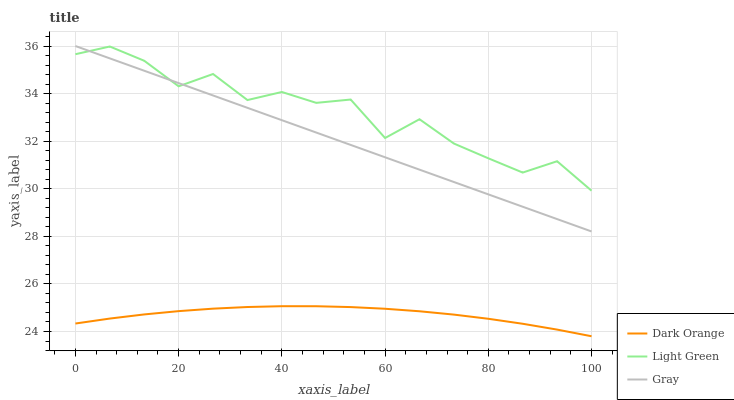Does Dark Orange have the minimum area under the curve?
Answer yes or no. Yes. Does Light Green have the maximum area under the curve?
Answer yes or no. Yes. Does Gray have the minimum area under the curve?
Answer yes or no. No. Does Gray have the maximum area under the curve?
Answer yes or no. No. Is Gray the smoothest?
Answer yes or no. Yes. Is Light Green the roughest?
Answer yes or no. Yes. Is Light Green the smoothest?
Answer yes or no. No. Is Gray the roughest?
Answer yes or no. No. Does Dark Orange have the lowest value?
Answer yes or no. Yes. Does Gray have the lowest value?
Answer yes or no. No. Does Gray have the highest value?
Answer yes or no. Yes. Does Light Green have the highest value?
Answer yes or no. No. Is Dark Orange less than Light Green?
Answer yes or no. Yes. Is Gray greater than Dark Orange?
Answer yes or no. Yes. Does Gray intersect Light Green?
Answer yes or no. Yes. Is Gray less than Light Green?
Answer yes or no. No. Is Gray greater than Light Green?
Answer yes or no. No. Does Dark Orange intersect Light Green?
Answer yes or no. No. 